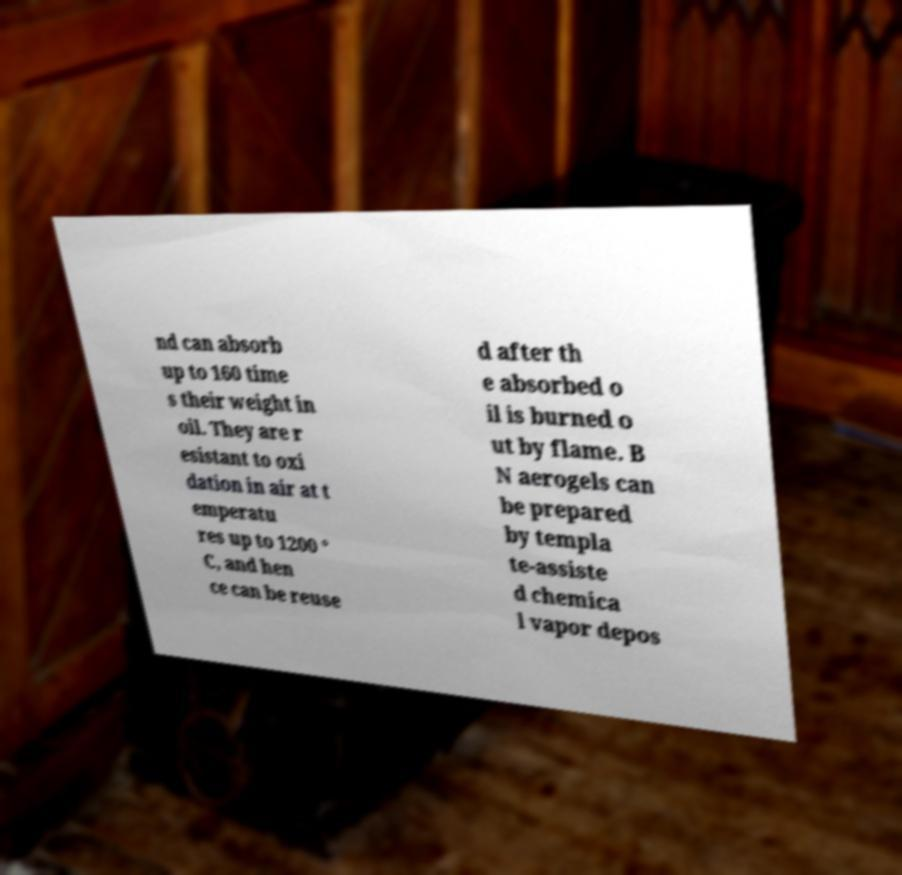Please read and relay the text visible in this image. What does it say? nd can absorb up to 160 time s their weight in oil. They are r esistant to oxi dation in air at t emperatu res up to 1200 ° C, and hen ce can be reuse d after th e absorbed o il is burned o ut by flame. B N aerogels can be prepared by templa te-assiste d chemica l vapor depos 